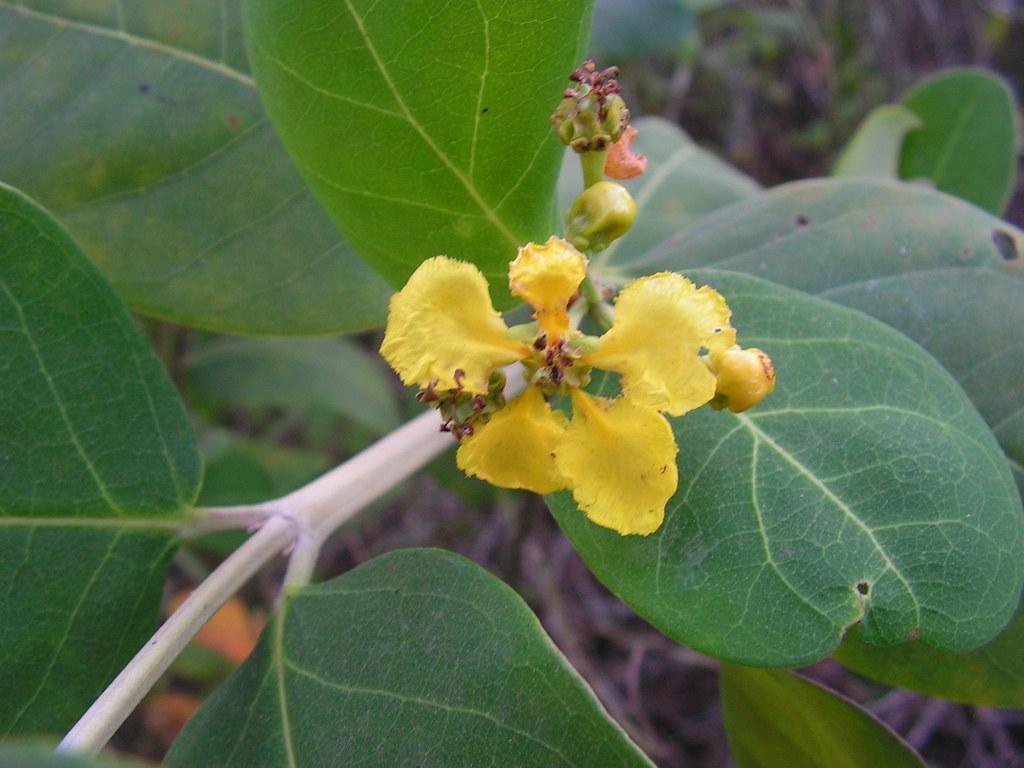Describe this image in one or two sentences. In the center of the image there is a flower to the plant. 